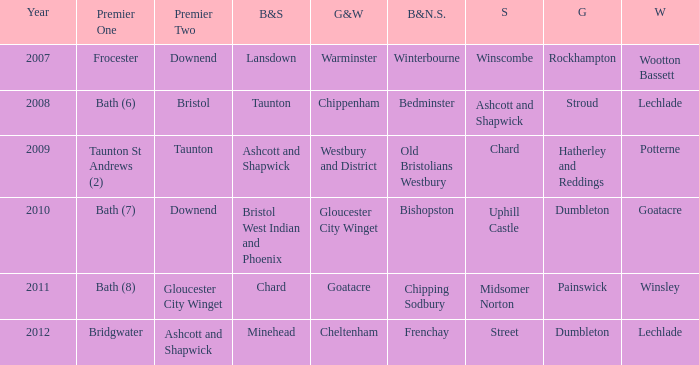What is the glos & wilts where the bristol & somerset is lansdown? Warminster. 